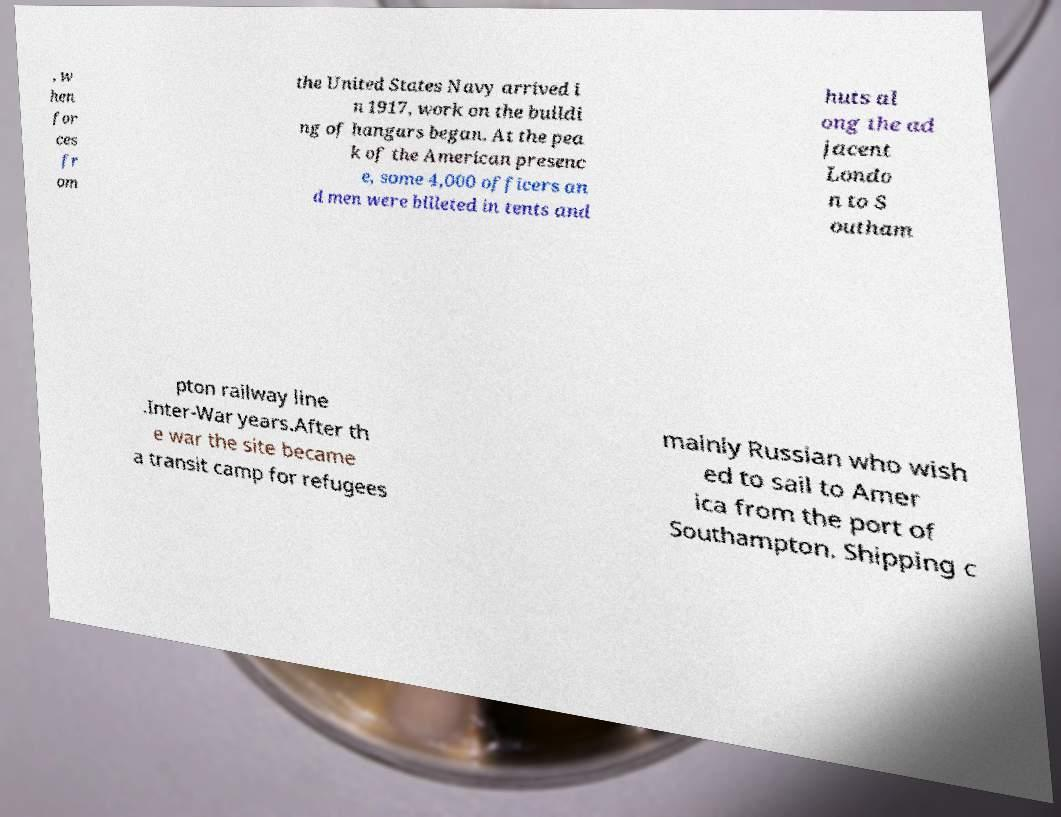Could you extract and type out the text from this image? , w hen for ces fr om the United States Navy arrived i n 1917, work on the buildi ng of hangars began. At the pea k of the American presenc e, some 4,000 officers an d men were billeted in tents and huts al ong the ad jacent Londo n to S outham pton railway line .Inter-War years.After th e war the site became a transit camp for refugees mainly Russian who wish ed to sail to Amer ica from the port of Southampton. Shipping c 